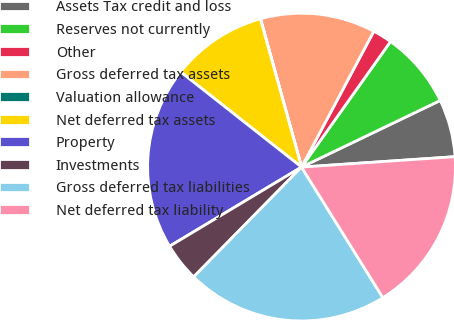Convert chart to OTSL. <chart><loc_0><loc_0><loc_500><loc_500><pie_chart><fcel>Assets Tax credit and loss<fcel>Reserves not currently<fcel>Other<fcel>Gross deferred tax assets<fcel>Valuation allowance<fcel>Net deferred tax assets<fcel>Property<fcel>Investments<fcel>Gross deferred tax liabilities<fcel>Net deferred tax liability<nl><fcel>6.05%<fcel>8.06%<fcel>2.03%<fcel>12.08%<fcel>0.02%<fcel>10.07%<fcel>19.22%<fcel>4.04%<fcel>21.23%<fcel>17.21%<nl></chart> 